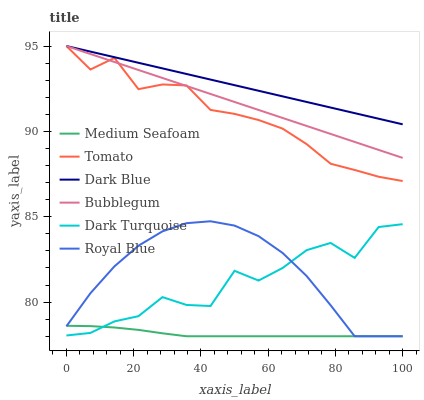Does Medium Seafoam have the minimum area under the curve?
Answer yes or no. Yes. Does Dark Blue have the maximum area under the curve?
Answer yes or no. Yes. Does Royal Blue have the minimum area under the curve?
Answer yes or no. No. Does Royal Blue have the maximum area under the curve?
Answer yes or no. No. Is Dark Blue the smoothest?
Answer yes or no. Yes. Is Dark Turquoise the roughest?
Answer yes or no. Yes. Is Royal Blue the smoothest?
Answer yes or no. No. Is Royal Blue the roughest?
Answer yes or no. No. Does Dark Turquoise have the lowest value?
Answer yes or no. No. Does Dark Blue have the highest value?
Answer yes or no. Yes. Does Royal Blue have the highest value?
Answer yes or no. No. Is Medium Seafoam less than Dark Blue?
Answer yes or no. Yes. Is Tomato greater than Royal Blue?
Answer yes or no. Yes. Does Medium Seafoam intersect Dark Blue?
Answer yes or no. No. 